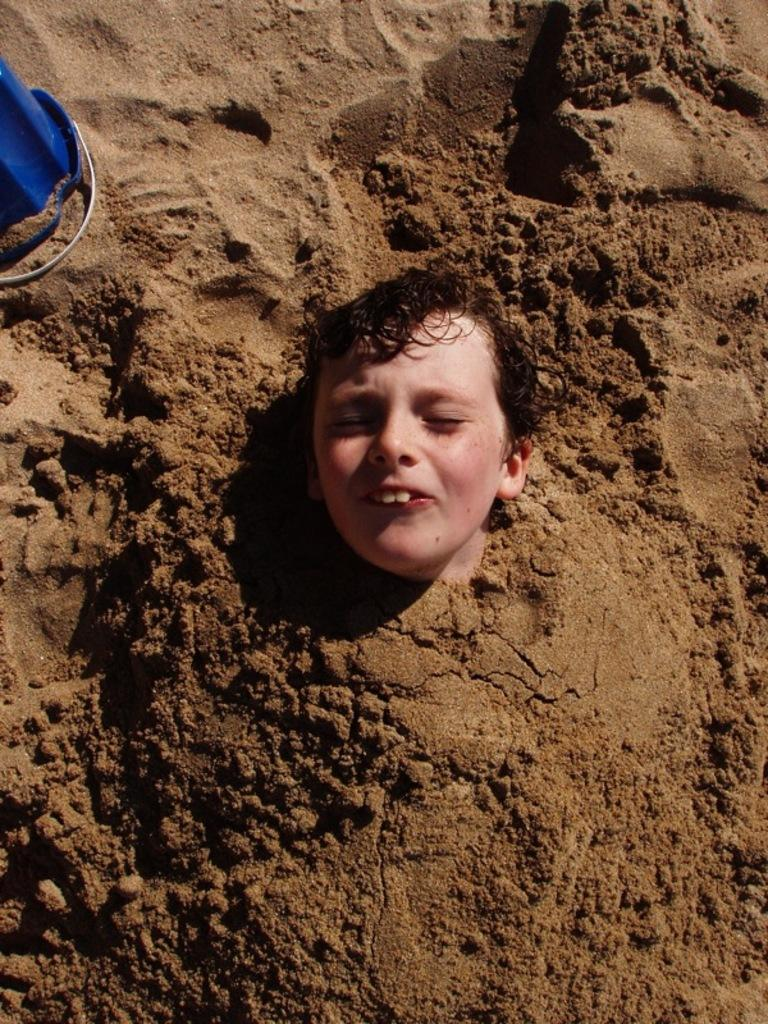What is the main subject of the image? The main subject of the image is a person's head. Where is the person's head located in the image? The person's head is on the mud. What type of linen is being used to cover the basket in the image? There is no basket or linen present in the image; it only features a person's head on the mud. 